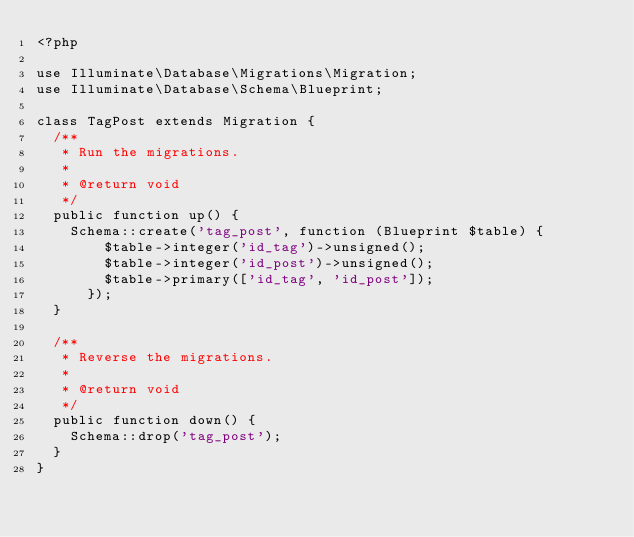Convert code to text. <code><loc_0><loc_0><loc_500><loc_500><_PHP_><?php

use Illuminate\Database\Migrations\Migration;
use Illuminate\Database\Schema\Blueprint;

class TagPost extends Migration {
	/**
	 * Run the migrations.
	 *
	 * @return void
	 */
	public function up() {
		Schema::create('tag_post', function (Blueprint $table) {
				$table->integer('id_tag')->unsigned();
				$table->integer('id_post')->unsigned();
				$table->primary(['id_tag', 'id_post']);
			});
	}

	/**
	 * Reverse the migrations.
	 *
	 * @return void
	 */
	public function down() {
		Schema::drop('tag_post');
	}
}
</code> 